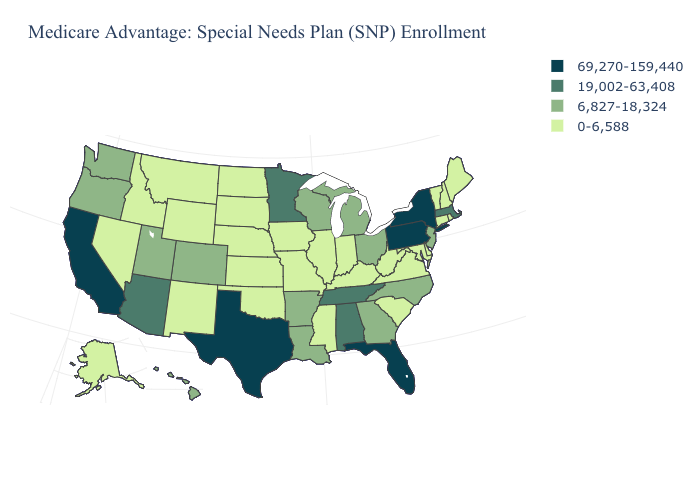Among the states that border California , which have the highest value?
Give a very brief answer. Arizona. What is the value of Wisconsin?
Give a very brief answer. 6,827-18,324. What is the lowest value in the USA?
Be succinct. 0-6,588. What is the highest value in states that border North Dakota?
Be succinct. 19,002-63,408. What is the value of Arkansas?
Concise answer only. 6,827-18,324. What is the lowest value in the USA?
Give a very brief answer. 0-6,588. Name the states that have a value in the range 69,270-159,440?
Write a very short answer. California, Florida, New York, Pennsylvania, Texas. What is the value of Ohio?
Quick response, please. 6,827-18,324. What is the value of Maryland?
Concise answer only. 0-6,588. What is the value of New Jersey?
Write a very short answer. 6,827-18,324. What is the value of North Dakota?
Short answer required. 0-6,588. What is the value of Massachusetts?
Concise answer only. 19,002-63,408. Among the states that border Ohio , does Michigan have the lowest value?
Be succinct. No. What is the value of Georgia?
Give a very brief answer. 6,827-18,324. Which states have the highest value in the USA?
Answer briefly. California, Florida, New York, Pennsylvania, Texas. 